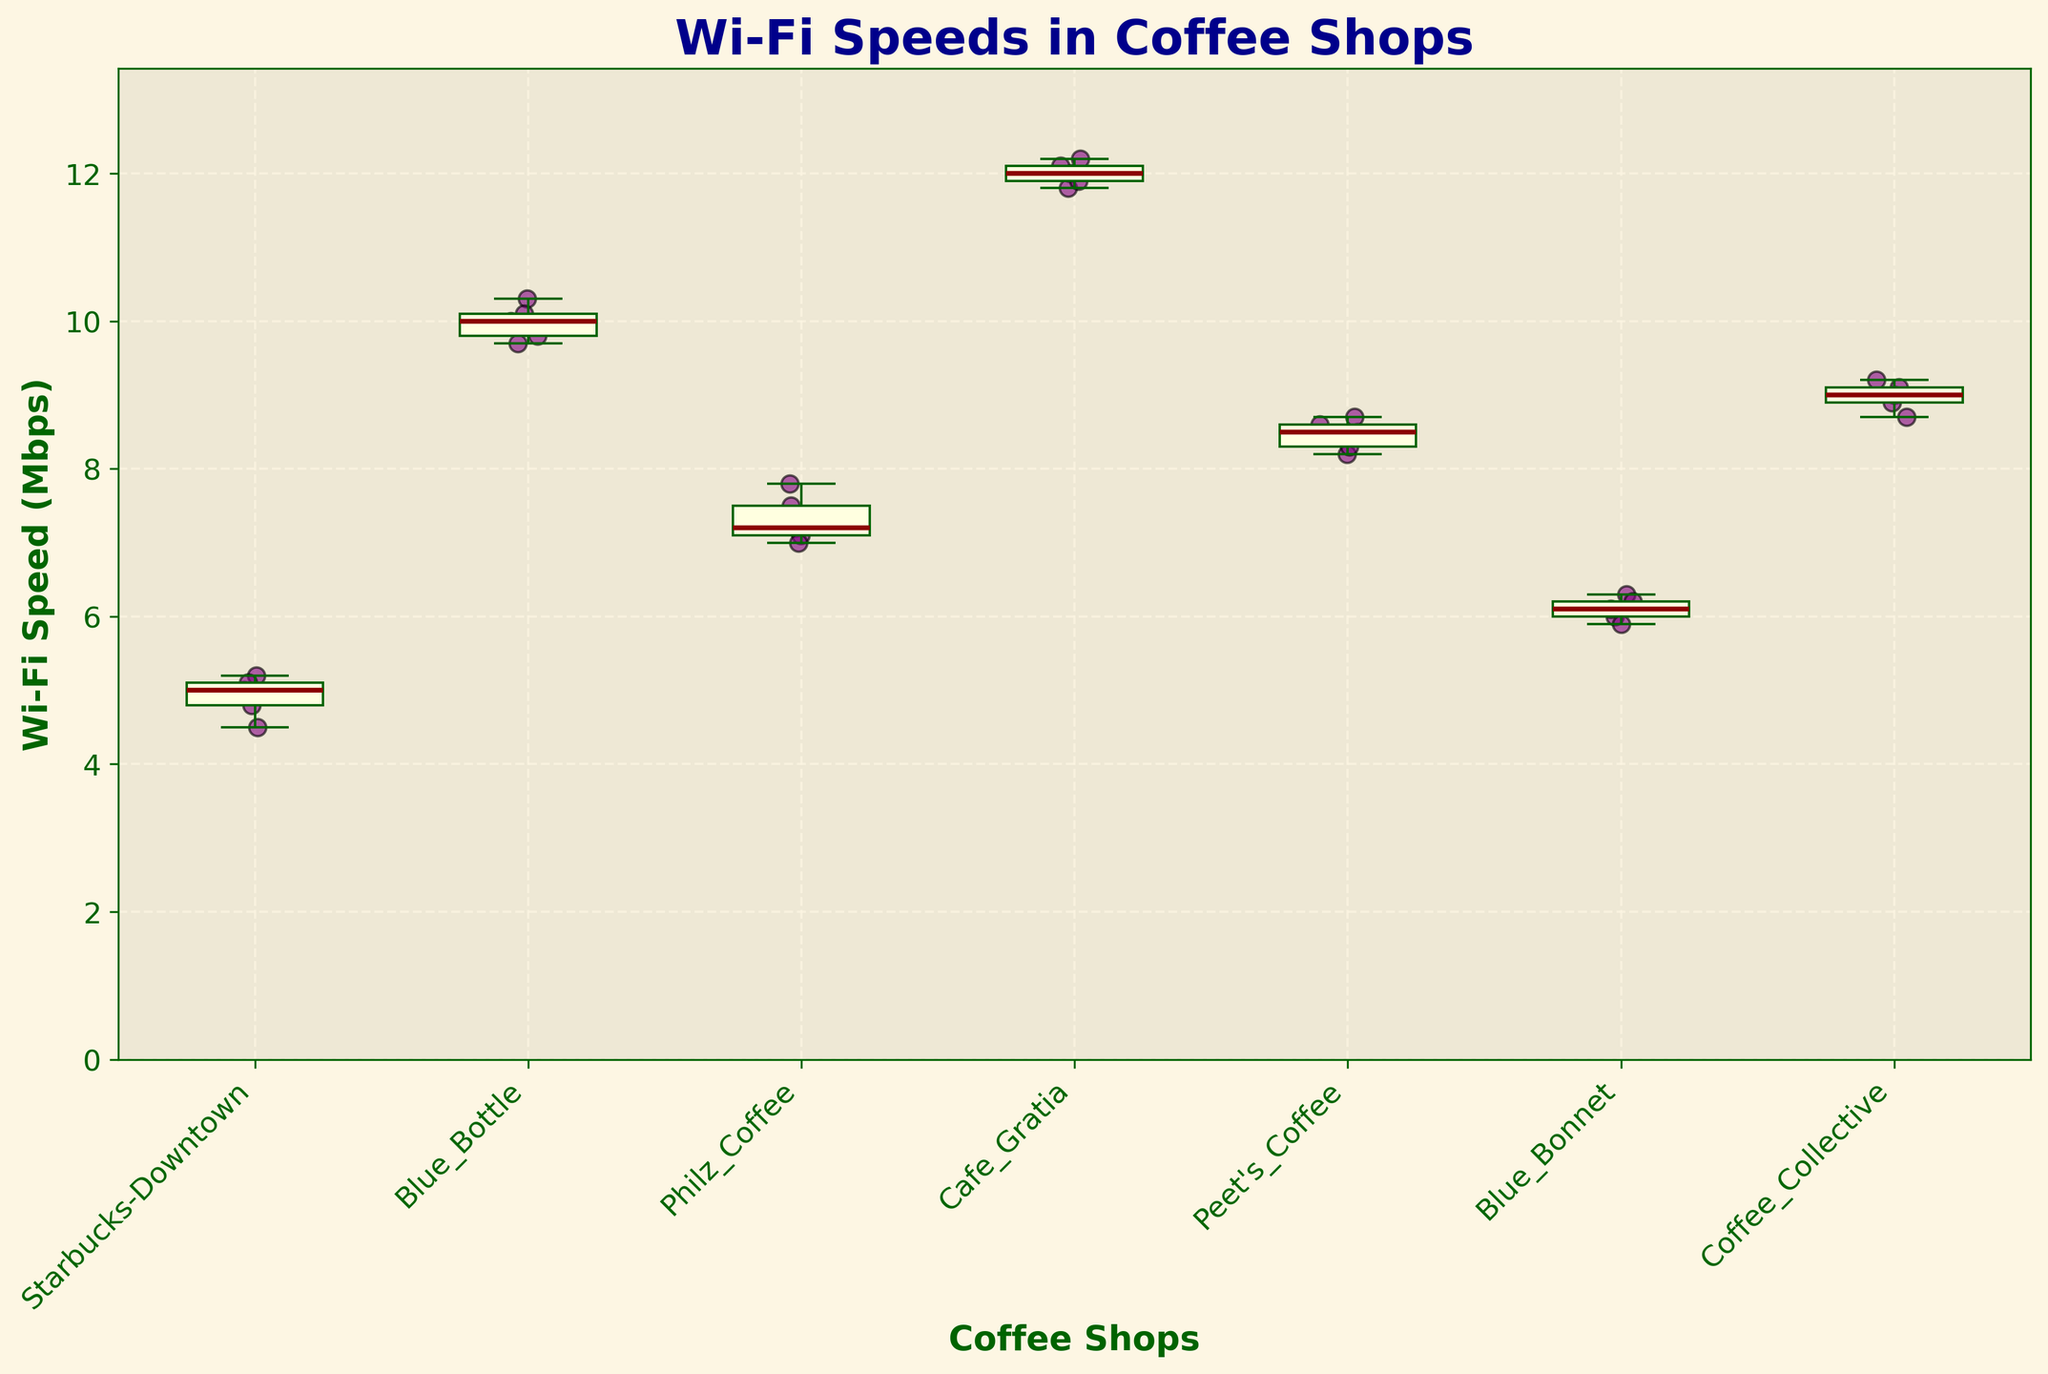Which coffee shop has the highest median Wi-Fi speed? To find the coffee shop with the highest median Wi-Fi speed, look at the central line inside each box. The highest central line corresponds to Cafe Gratia.
Answer: Cafe Gratia Which coffee shop has the lowest median Wi-Fi speed? To identify the coffee shop with the lowest median Wi-Fi speed, check the central line inside each box. The coffee shop with the lowest central line is Starbucks-Downtown.
Answer: Starbucks-Downtown What is the range of Wi-Fi speeds for Blue Bottle? The range of Wi-Fi speeds is found by subtracting the minimum Wi-Fi speed from the maximum Wi-Fi speed for Blue Bottle. The minimum is 9.7 Mbps and the maximum is 10.3 Mbps, giving a range of 10.3 - 9.7 = 0.6 Mbps.
Answer: 0.6 Mbps How do the Wi-Fi speeds of Blue Bonnet compare to Coffee Collective? Comparing the box plots for Blue Bonnet and Coffee Collective, the median of Coffee Collective is higher than that of Blue Bonnet, and the overall spread (range of whiskers) of Coffee Collective is greater than Blue Bonnet.
Answer: Coffee Collective Wi-Fi speeds are higher and more spread out Which coffee shop exhibits the most variability in Wi-Fi speeds? Variability can be determined by looking at the length of the whiskers and the IQR (box height). Cafe Gratia shows the longest whiskers and a larger IQR.
Answer: Cafe Gratia Are there any outliers in the Wi-Fi speeds of Starbucks-Downtown? Outliers are typically shown as individual scatter points outside the whiskers. Checking the Starbucks-Downtown box plot, there are no scatter points marked as outliers.
Answer: No What is the median Wi-Fi speed for Philz Coffee? The median Wi-Fi speed is the center line of the box in Philz Coffee's box plot. The median line is at 7.2 Mbps.
Answer: 7.2 Mbps Which coffee shop has the highest individual Wi-Fi speed recording? The highest individual Wi-Fi speed recording is represented by the highest scatter point on the plot, which is approximately 12.2 Mbps for Cafe Gratia.
Answer: Cafe Gratia How does the variability of Wi-Fi speeds in Peet's Coffee compare to Starbucks-Downtown? The variability is represented by the length of the whiskers and the IQR. Peet's Coffee has a tighter range and smaller IQR compared to Starbucks-Downtown, indicating less variability.
Answer: Peet's Coffee has less variability What comparative insights can you gain about Blue Bottle and Blue Bonnet? Blue Bottle shows a higher median and tighter range (less variability) than Blue Bonnet. Blue Bottle's median is around 10.0 Mbps, whereas Blue Bonnet's median is around 6.1 Mbps.
Answer: Blue Bottle has a higher median and less variability than Blue Bonnet 